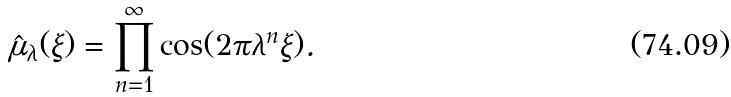<formula> <loc_0><loc_0><loc_500><loc_500>\hat { \mu } _ { \lambda } ( \xi ) = \prod _ { n = 1 } ^ { \infty } \cos ( 2 \pi \lambda ^ { n } \xi ) .</formula> 